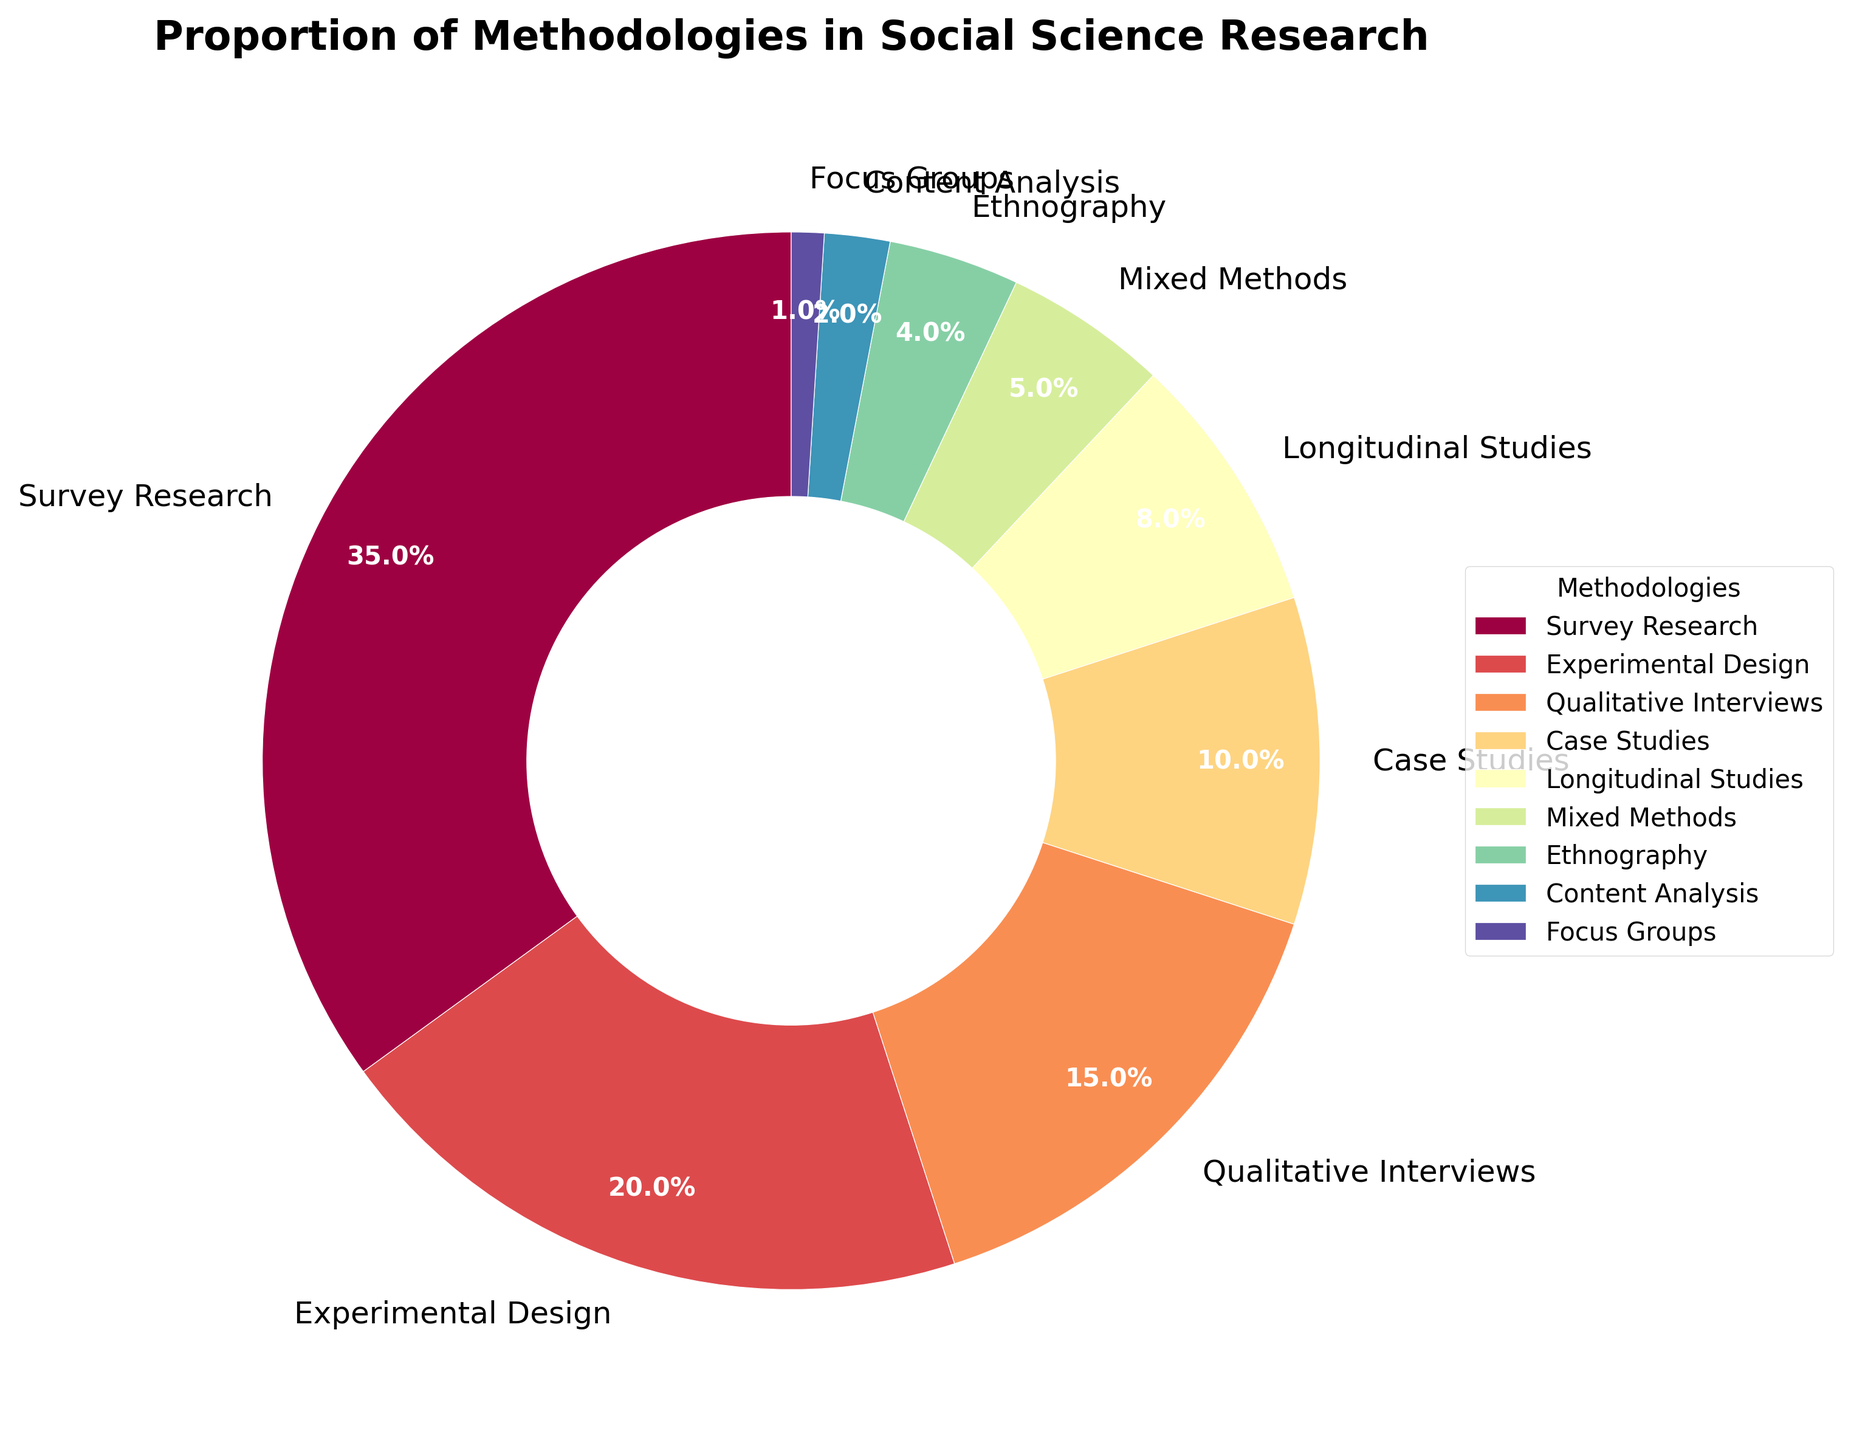What is the most commonly used methodology in social science research according to the figure? The largest wedge in the pie chart represents the proportion of Survey Research, which is annotated as 35%. This indicates that Survey Research is the most commonly used methodology.
Answer: Survey Research Which methodologies combined account for exactly half of the studies? Adding up the percentages of Survey Research (35%) and Experimental Design (20%) gives us 55%, which is more than half. However, considering only Survey Research (35%) and Qualitative Interviews (15%) totals 50%, covering half of the studies.
Answer: Survey Research and Qualitative Interviews How much more preferred is Survey Research compared to Ethnography? Survey Research accounts for 35% while Ethnography accounts for 4%. To find the preference difference, subtract the smaller percentage from the larger: 35% - 4% = 31%.
Answer: 31% Do Case Studies represent a larger proportion of methodologies than Longitudinal Studies? From the pie chart, Case Studies represent 10% while Longitudinal Studies represent 8%. Comparing these two values, we see that Case Studies have a larger proportion.
Answer: Yes Among the methodologies used, which one is the least represented? The smallest wedge in the pie chart, labeled 1%, represents Focus Groups, making it the least represented methodology.
Answer: Focus Groups What is the combined proportion of methodologies that individually have less than 10% usage? Ethnography (4%), Content Analysis (2%), and Focus Groups (1%) each have less than 10%. Their combined proportion is 4% + 2% + 1% = 7%.
Answer: 7% Compare the combined proportion of Survey Research and Experimental Design to all other methodologies combined. Which is greater? Survey Research and Experimental Design together make up 35% + 20% = 55%. All other methodologies’ combined proportion is 15% (Qualitative Interviews) + 10% (Case Studies) + 8% (Longitudinal Studies) + 5% (Mixed Methods) + 4% (Ethnography) + 2% (Content Analysis) + 1% (Focus Groups) = 45%. 55% is greater than 45%.
Answer: Survey Research and Experimental Design What proportion of methodologies falls under 20% each? Apart from Survey Research (35%) and Experimental Design (20%), all other methodologies fall under 20%. Collectively, these are Qualitative Interviews (15%), Case Studies (10%), Longitudinal Studies (8%), Mixed Methods (5%), Ethnography (4%), Content Analysis (2%), and Focus Groups (1%).
Answer: Seven methodologies Which methodologies have similar visual impression (colors) as per the figure? The pie chart uses a gradual color spectrum. Visual similarities can be noted between Ethnography (near the light green-blue spectrum), Longitudinal Studies (light green), Content Analysis (blue-green), and Mixed Methods (closely following the blue spectrum).
Answer: Ethnography, Longitudinal Studies, Content Analysis, and Mixed Methods Identify if any two methodologies have a combined proportion of less than 10%. Ethnography (4%) and Content Analysis (2%) combined give 4% + 2% = 6%, which is less than 10%. Similarly, Content Analysis (2%) and Focus Groups (1%) combined give 2% + 1% = 3%, also less than 10%.
Answer: Ethnography and Content Analysis; Content Analysis and Focus Groups 